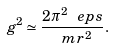Convert formula to latex. <formula><loc_0><loc_0><loc_500><loc_500>g ^ { 2 } \simeq \frac { 2 \pi ^ { 2 } \ e p s } { \ m r ^ { \, 2 } } .</formula> 